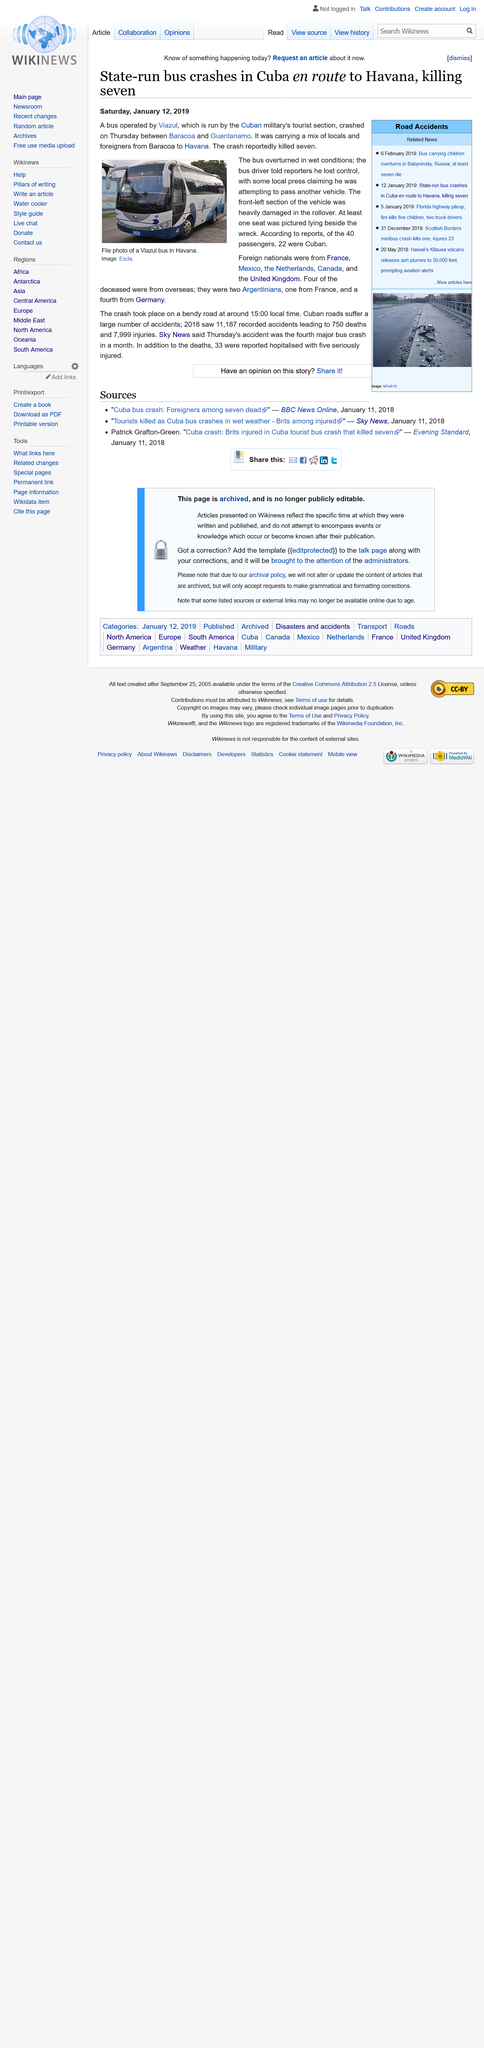Identify some key points in this picture. The accident occurred in Cuba. The bus was driving in wet conditions. The article was published on December 1st, 2019. 